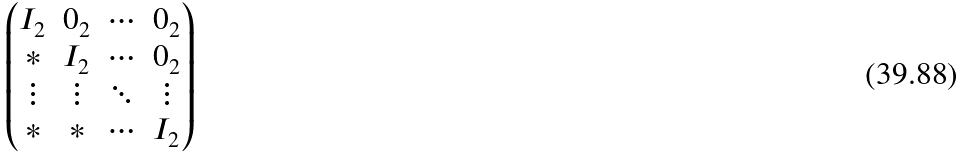<formula> <loc_0><loc_0><loc_500><loc_500>\begin{pmatrix} I _ { 2 } & 0 _ { 2 } & \cdots & 0 _ { 2 } \\ * & I _ { 2 } & \cdots & 0 _ { 2 } \\ \vdots & \vdots & \ddots & \vdots \\ * & * & \cdots & I _ { 2 } \end{pmatrix}</formula> 